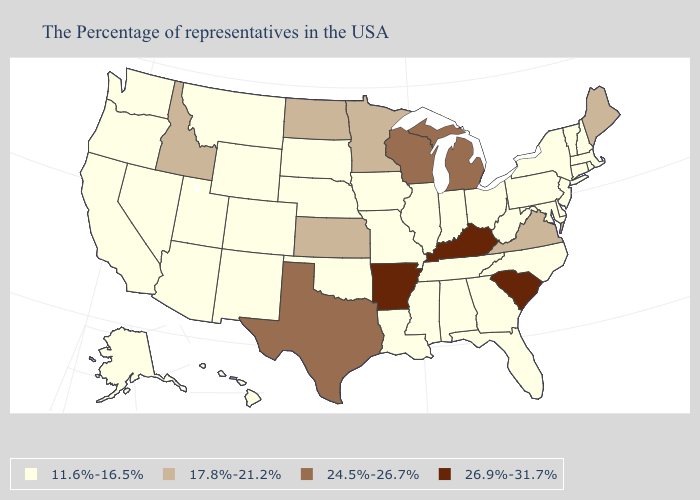Does Georgia have the same value as Kansas?
Concise answer only. No. Name the states that have a value in the range 17.8%-21.2%?
Be succinct. Maine, Virginia, Minnesota, Kansas, North Dakota, Idaho. Name the states that have a value in the range 24.5%-26.7%?
Short answer required. Michigan, Wisconsin, Texas. What is the value of Rhode Island?
Answer briefly. 11.6%-16.5%. What is the lowest value in the Northeast?
Keep it brief. 11.6%-16.5%. Name the states that have a value in the range 26.9%-31.7%?
Short answer required. South Carolina, Kentucky, Arkansas. What is the lowest value in states that border California?
Quick response, please. 11.6%-16.5%. How many symbols are there in the legend?
Concise answer only. 4. What is the value of Illinois?
Write a very short answer. 11.6%-16.5%. What is the value of Massachusetts?
Give a very brief answer. 11.6%-16.5%. Which states have the lowest value in the West?
Be succinct. Wyoming, Colorado, New Mexico, Utah, Montana, Arizona, Nevada, California, Washington, Oregon, Alaska, Hawaii. Does Massachusetts have the same value as Kentucky?
Be succinct. No. What is the lowest value in the USA?
Short answer required. 11.6%-16.5%. Name the states that have a value in the range 11.6%-16.5%?
Concise answer only. Massachusetts, Rhode Island, New Hampshire, Vermont, Connecticut, New York, New Jersey, Delaware, Maryland, Pennsylvania, North Carolina, West Virginia, Ohio, Florida, Georgia, Indiana, Alabama, Tennessee, Illinois, Mississippi, Louisiana, Missouri, Iowa, Nebraska, Oklahoma, South Dakota, Wyoming, Colorado, New Mexico, Utah, Montana, Arizona, Nevada, California, Washington, Oregon, Alaska, Hawaii. Does Maine have the highest value in the Northeast?
Quick response, please. Yes. 